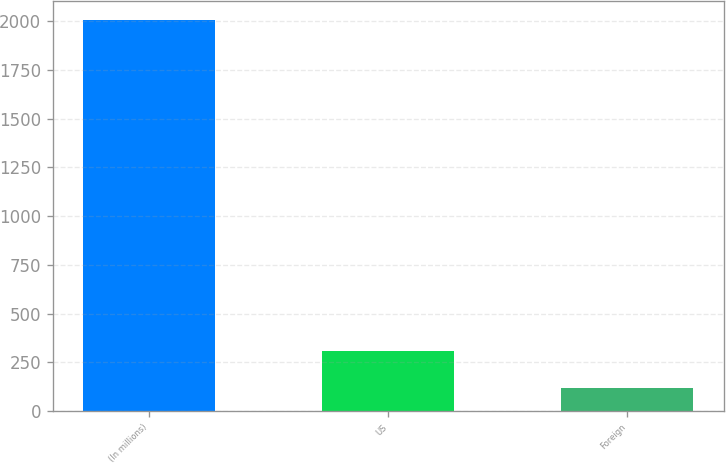<chart> <loc_0><loc_0><loc_500><loc_500><bar_chart><fcel>(In millions)<fcel>US<fcel>Foreign<nl><fcel>2006<fcel>306.71<fcel>117.9<nl></chart> 